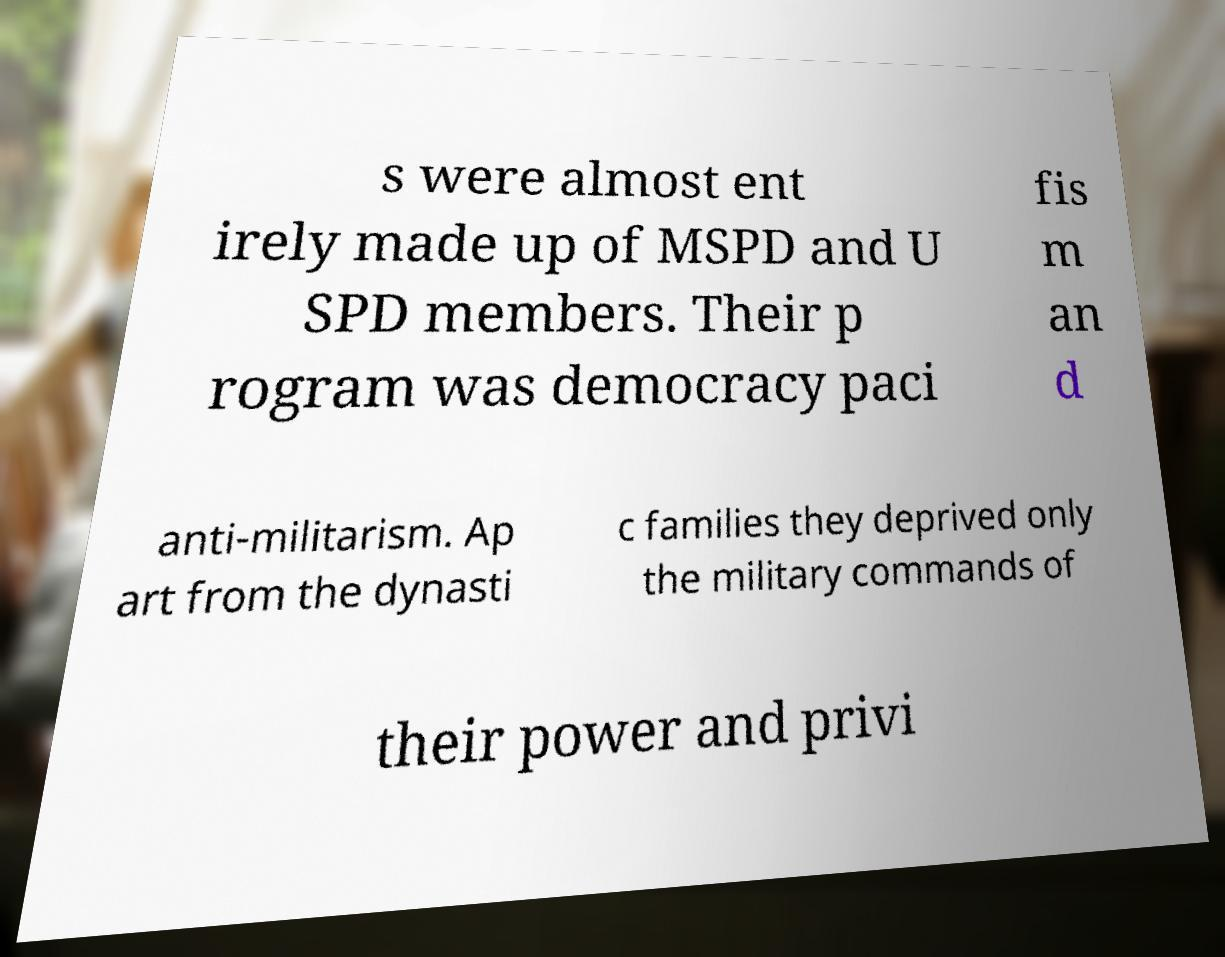What messages or text are displayed in this image? I need them in a readable, typed format. s were almost ent irely made up of MSPD and U SPD members. Their p rogram was democracy paci fis m an d anti-militarism. Ap art from the dynasti c families they deprived only the military commands of their power and privi 